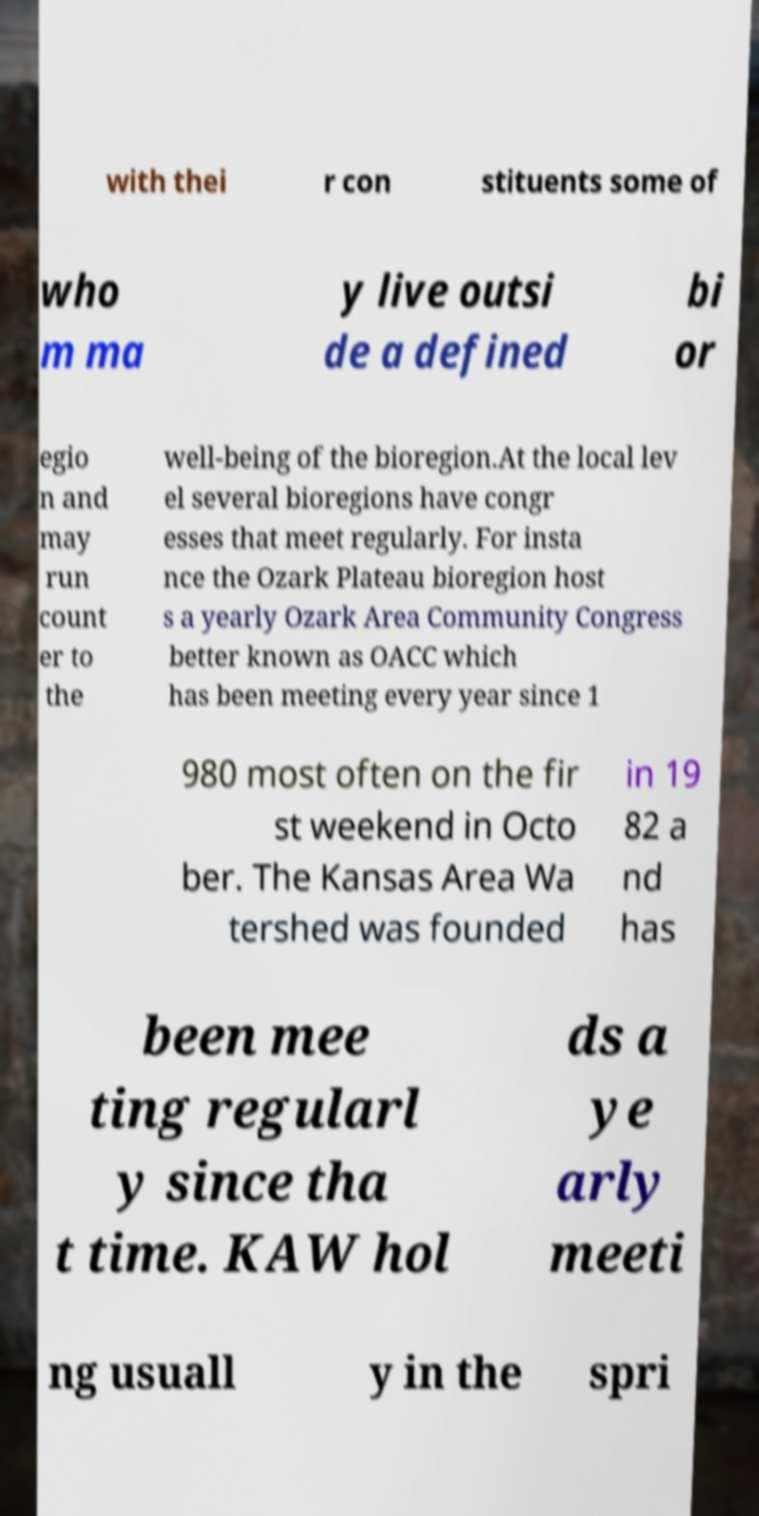There's text embedded in this image that I need extracted. Can you transcribe it verbatim? with thei r con stituents some of who m ma y live outsi de a defined bi or egio n and may run count er to the well-being of the bioregion.At the local lev el several bioregions have congr esses that meet regularly. For insta nce the Ozark Plateau bioregion host s a yearly Ozark Area Community Congress better known as OACC which has been meeting every year since 1 980 most often on the fir st weekend in Octo ber. The Kansas Area Wa tershed was founded in 19 82 a nd has been mee ting regularl y since tha t time. KAW hol ds a ye arly meeti ng usuall y in the spri 